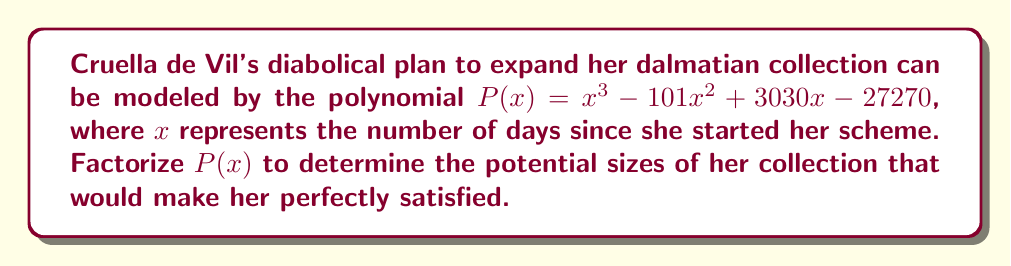What is the answer to this math problem? To factorize this polynomial, we'll follow these steps:

1) First, let's check if there are any rational roots using the rational root theorem. The possible rational roots are the factors of the constant term: $\pm 1, \pm 2, \pm 3, \pm 5, \pm 6, \pm 10, \pm 15, \pm 30, \pm 45, \pm 90, \pm 101, \pm 270, \pm 909, \pm 1818, \pm 2727, \pm 5454, \pm 9090, \pm 13635, \pm 27270$

2) Testing these values, we find that 30 is a root. So $(x - 30)$ is a factor.

3) Dividing $P(x)$ by $(x - 30)$:

   $$\frac{x^3 - 101x^2 + 3030x - 27270}{x - 30} = x^2 - 71x + 909$$

4) Now we need to factorize $x^2 - 71x + 909$. Let's use the quadratic formula:

   $$x = \frac{-b \pm \sqrt{b^2 - 4ac}}{2a}$$

   Where $a=1$, $b=-71$, and $c=909$

5) Calculating:

   $$x = \frac{71 \pm \sqrt{71^2 - 4(1)(909)}}{2(1)} = \frac{71 \pm \sqrt{5041 - 3636}}{2} = \frac{71 \pm \sqrt{1405}}{2}$$

6) This simplifies to:

   $$x = \frac{71 \pm 37.5}{2}$$

7) So the other two roots are:

   $$x = \frac{71 + 37.5}{2} = 54.25\text{ and }\frac{71 - 37.5}{2} = 16.75$$

8) Since these aren't integers, we can't factorize further over the integers.

Therefore, the factored form of $P(x)$ is:

$$P(x) = (x - 30)(x - 54.25)(x - 16.75)$$
Answer: $P(x) = (x - 30)(x - 54.25)(x - 16.75)$ 